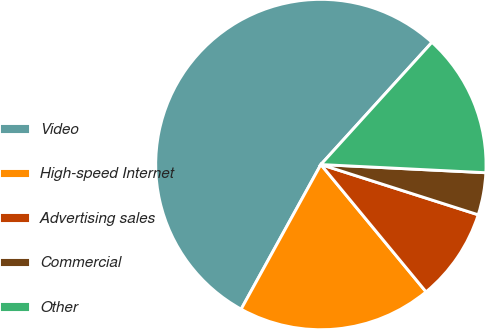Convert chart to OTSL. <chart><loc_0><loc_0><loc_500><loc_500><pie_chart><fcel>Video<fcel>High-speed Internet<fcel>Advertising sales<fcel>Commercial<fcel>Other<nl><fcel>53.72%<fcel>19.01%<fcel>9.09%<fcel>4.13%<fcel>14.05%<nl></chart> 